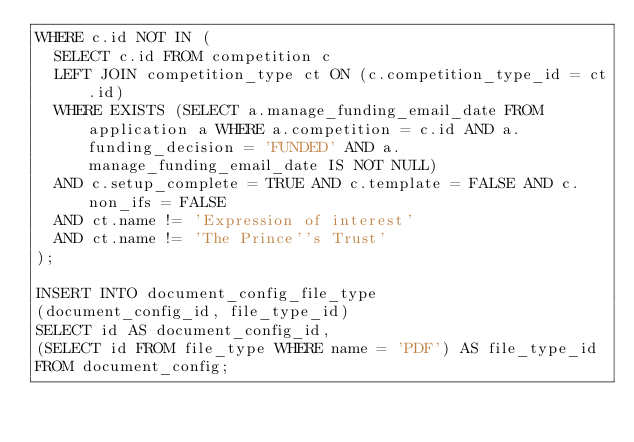<code> <loc_0><loc_0><loc_500><loc_500><_SQL_>WHERE c.id NOT IN (
	SELECT c.id FROM competition c
	LEFT JOIN competition_type ct ON (c.competition_type_id = ct.id)
	WHERE EXISTS (SELECT a.manage_funding_email_date FROM application a WHERE a.competition = c.id AND a.funding_decision = 'FUNDED' AND a.manage_funding_email_date IS NOT NULL)
	AND c.setup_complete = TRUE AND c.template = FALSE AND c.non_ifs = FALSE
	AND ct.name != 'Expression of interest'
	AND ct.name != 'The Prince''s Trust'
);

INSERT INTO document_config_file_type
(document_config_id, file_type_id)
SELECT id AS document_config_id,
(SELECT id FROM file_type WHERE name = 'PDF') AS file_type_id
FROM document_config;



</code> 